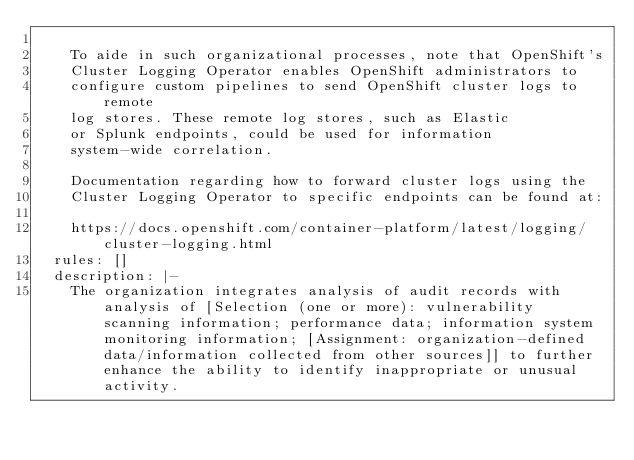Convert code to text. <code><loc_0><loc_0><loc_500><loc_500><_YAML_>
    To aide in such organizational processes, note that OpenShift's
    Cluster Logging Operator enables OpenShift administrators to
    configure custom pipelines to send OpenShift cluster logs to remote
    log stores. These remote log stores, such as Elastic
    or Splunk endpoints, could be used for information
    system-wide correlation.

    Documentation regarding how to forward cluster logs using the
    Cluster Logging Operator to specific endpoints can be found at:

    https://docs.openshift.com/container-platform/latest/logging/cluster-logging.html
  rules: []
  description: |-
    The organization integrates analysis of audit records with analysis of [Selection (one or more): vulnerability scanning information; performance data; information system monitoring information; [Assignment: organization-defined data/information collected from other sources]] to further enhance the ability to identify inappropriate or unusual activity.
</code> 